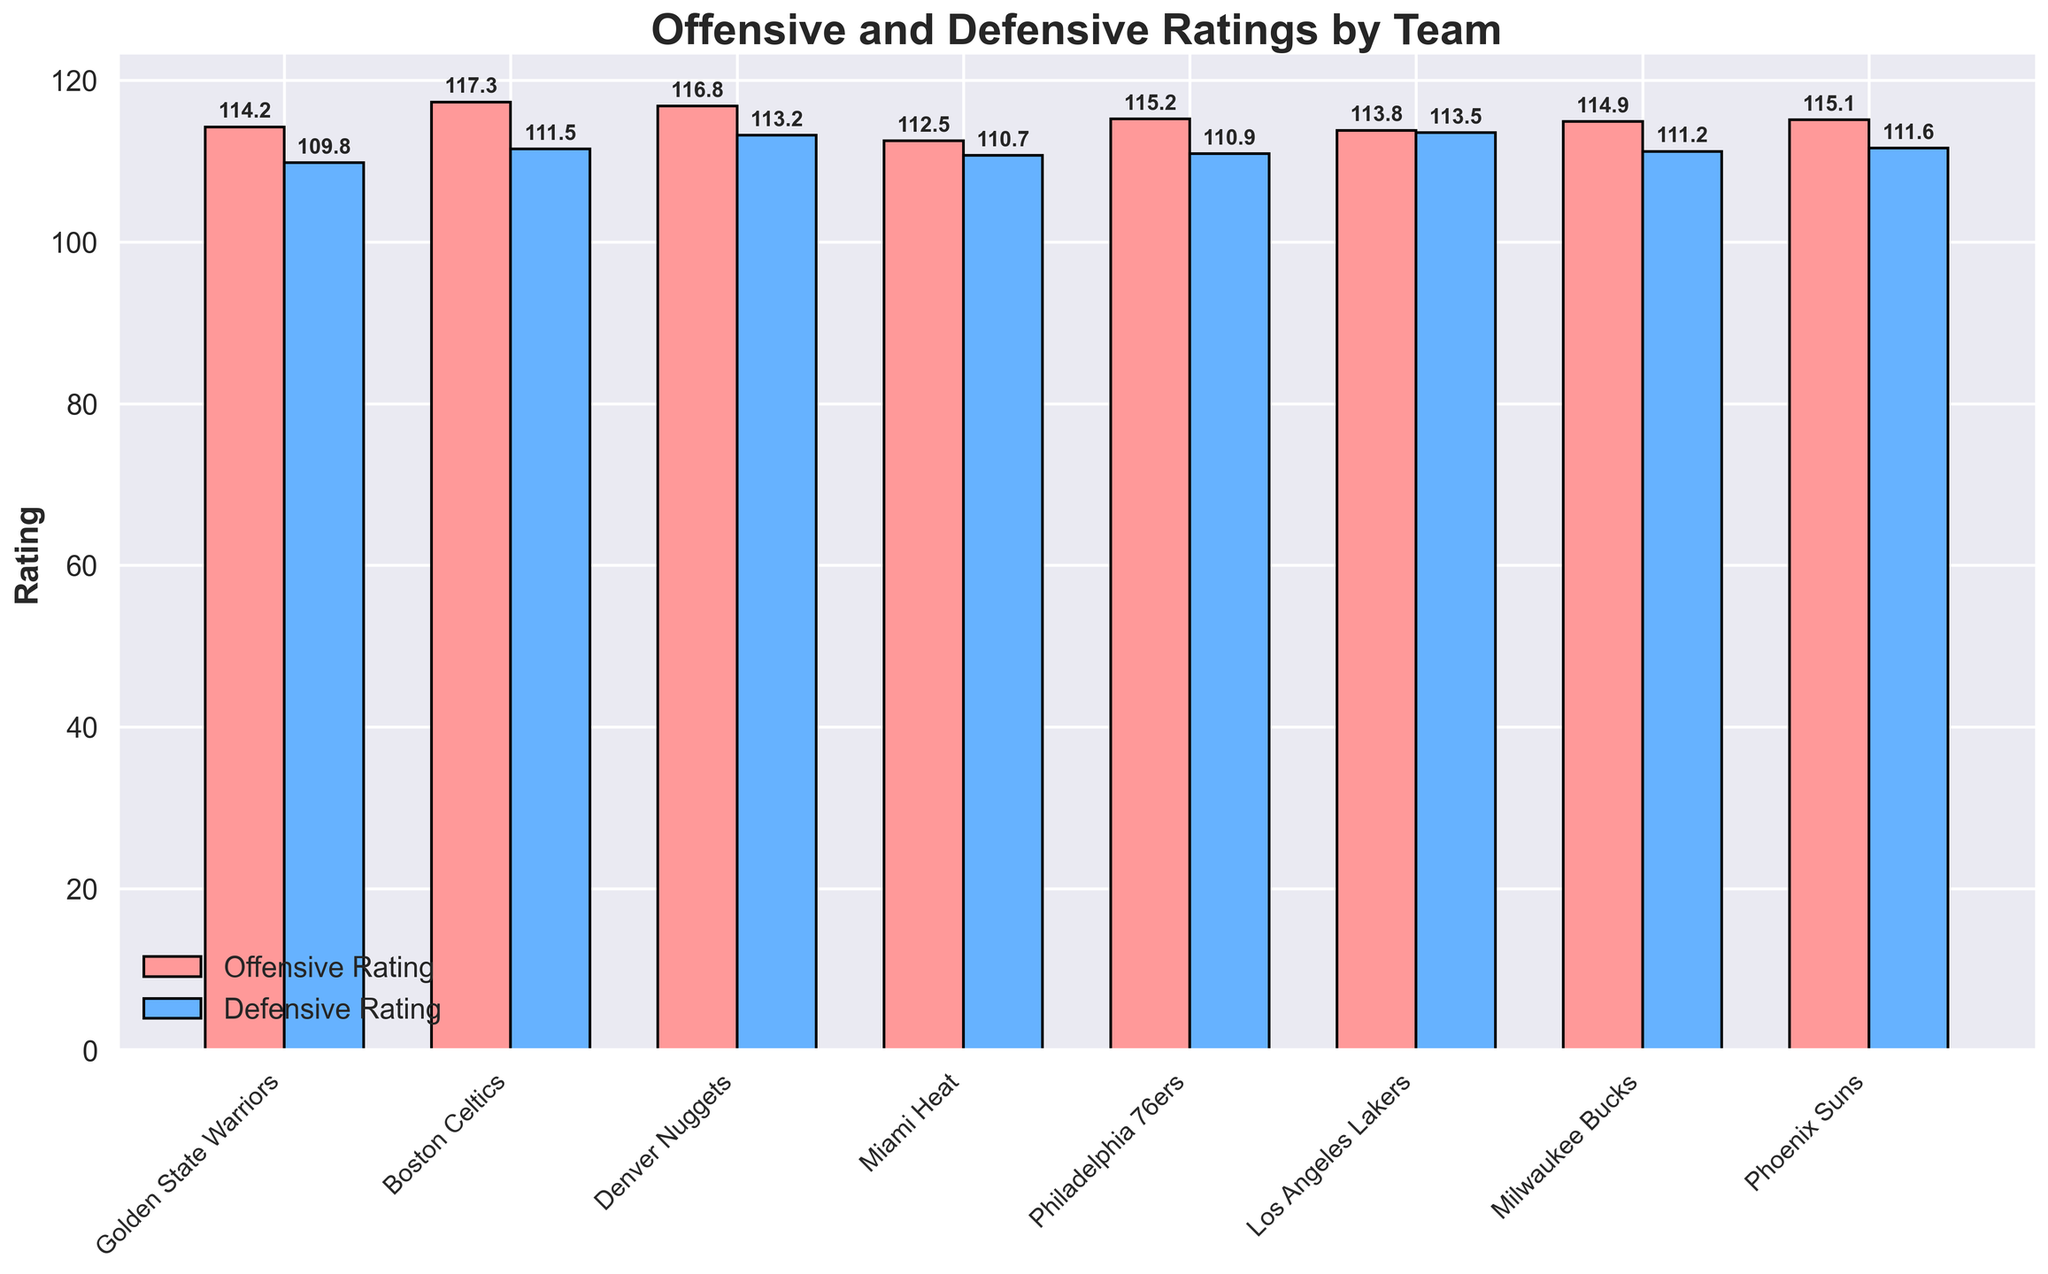What's the highest offensive rating among the teams? Observe the height of the red bars labeled as 'Offensive Rating' for each team. The Boston Celtics have the highest bar. The exact value shown above the bar is 117.3.
Answer: 117.3 Which team has the lowest defensive rating? Analyze the height of the blue bars labeled as 'Defensive Rating'. The Golden State Warriors' blue bar is the shortest, indicating the lowest defensive rating, which is 109.8.
Answer: Golden State Warriors What is the difference between the offensive and defensive ratings of the Los Angeles Lakers? Identify the heights of the respective red (Offensive Rating) and blue (Defensive Rating) bars for the Los Angeles Lakers. The offensive rating is 113.8, and the defensive rating is 113.5. Subtract the defensive rating from the offensive rating: 113.8 - 113.5 = 0.3.
Answer: 0.3 Which team has a better defensive rating: the Phoenix Suns or the Philadelphia 76ers? Compare the heights of the blue bars for both teams. The Phoenix Suns have a defensive rating of 111.6, and the Philadelphia 76ers have a defensive rating of 110.9. Since 110.9 < 111.6, the Philadelphia 76ers have a better defensive rating.
Answer: Philadelphia 76ers What is the average offensive rating of all teams? Add all the offensive ratings together: 114.2 + 117.3 + 116.8 + 112.5 + 115.2 + 113.8 + 114.9 + 115.1 = 919.8. Then, divide by the number of teams (8): 919.8 / 8 = 114.975.
Answer: 114.975 Which team has a smaller gap between their offensive and defensive ratings: the Milwaukee Bucks or the Miami Heat? Calculate the gap for each team. For the Milwaukee Bucks, it is 114.9 - 111.2 = 3.7. For the Miami Heat, it is 112.5 - 110.7 = 1.8. Compare the two values: 1.8 < 3.7. Therefore, the Miami Heat has a smaller gap.
Answer: Miami Heat Which team has a higher combined rating (sum of offensive and defensive ratings): the Denver Nuggets or the Boston Celtics? Calculate the combined rating for each team. For the Denver Nuggets, it is 116.8 + 113.2 = 230. For the Boston Celtics, it is 117.3 + 111.5 = 228.8. Compare the two values: 230 > 228.8. Therefore, the Denver Nuggets have a higher combined rating.
Answer: Denver Nuggets How does the defensive rating of the Milwaukee Bucks compare to the Miami Heat? Compare the heights of the blue bars for both teams. The Milwaukee Bucks have a defensive rating of 111.2, while the Miami Heat have a rating of 110.7. Since 111.2 > 110.7, the Milwaukee Bucks have a higher defensive rating than the Miami Heat.
Answer: Milwaukee Bucks Which team has the highest combined rating (sum of offensive and defensive ratings)? Calculate the combined ratings for all teams and compare them. Golden State Warriors: 114.2 + 109.8 = 224.0, Boston Celtics: 117.3 + 111.5 = 228.8, Denver Nuggets: 116.8 + 113.2 = 230.0, Miami Heat: 112.5 + 110.7 = 223.2, Philadelphia 76ers: 115.2 + 110.9 = 226.1, Los Angeles Lakers: 113.8 + 113.5 = 227.3, Milwaukee Bucks: 114.9 + 111.2 = 226.1, Phoenix Suns: 115.1 + 111.6 = 226.7. The Denver Nuggets have the highest combined rating with 230.0.
Answer: Denver Nuggets What is the range of offensive ratings for all teams? Identify the highest and lowest values of the red bars. The highest offensive rating is 117.3 (Boston Celtics) and the lowest is 112.5 (Miami Heat). The range is 117.3 - 112.5 = 4.8.
Answer: 4.8 